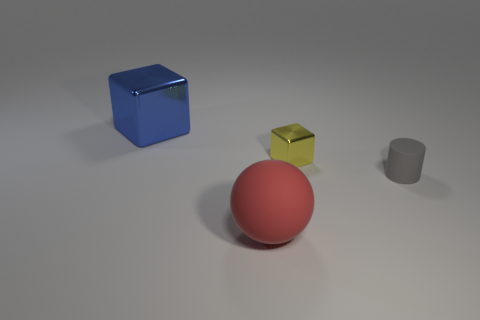There is a metallic block that is right of the cube that is to the left of the tiny yellow object; what color is it?
Offer a terse response. Yellow. What number of objects are both to the left of the tiny matte thing and to the right of the big block?
Make the answer very short. 2. What number of other small rubber objects have the same shape as the blue thing?
Keep it short and to the point. 0. Is the material of the gray cylinder the same as the large blue thing?
Provide a short and direct response. No. What is the shape of the large rubber object that is to the right of the shiny cube that is to the left of the large matte ball?
Make the answer very short. Sphere. How many tiny gray things are in front of the tiny object that is behind the small cylinder?
Make the answer very short. 1. The object that is to the left of the small yellow metal object and to the right of the large blue block is made of what material?
Ensure brevity in your answer.  Rubber. What is the shape of the metal thing that is the same size as the sphere?
Keep it short and to the point. Cube. The cube that is to the left of the large thing to the right of the block that is on the left side of the big matte object is what color?
Provide a succinct answer. Blue. How many things are either blue cubes that are left of the red rubber ball or small brown matte balls?
Give a very brief answer. 1. 